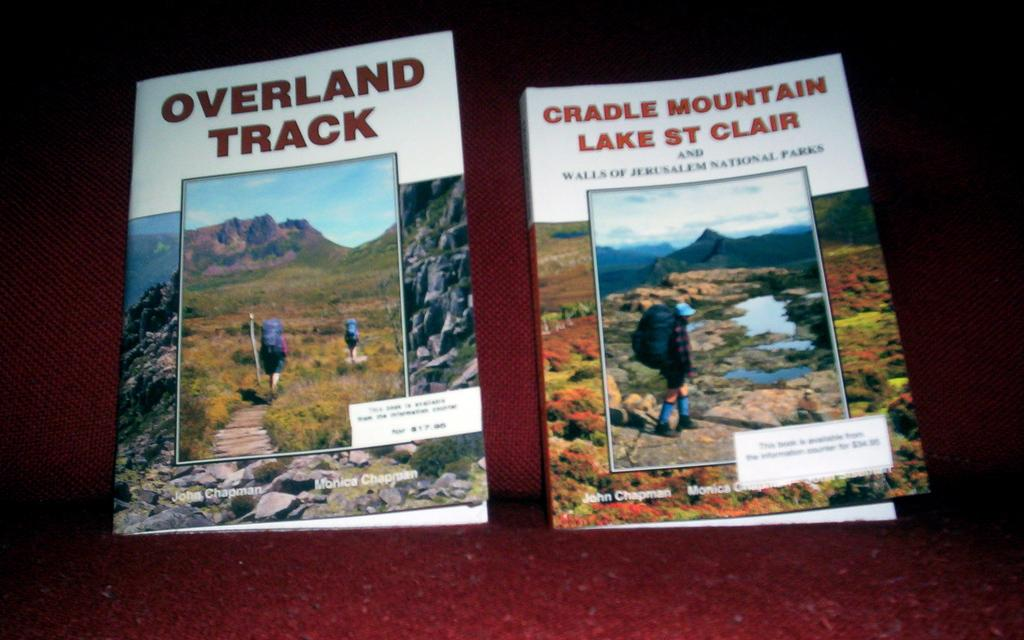<image>
Share a concise interpretation of the image provided. Two travel books titled Overland Track and Cradle Mountain Lake St. Clair display nature images on their covers. 